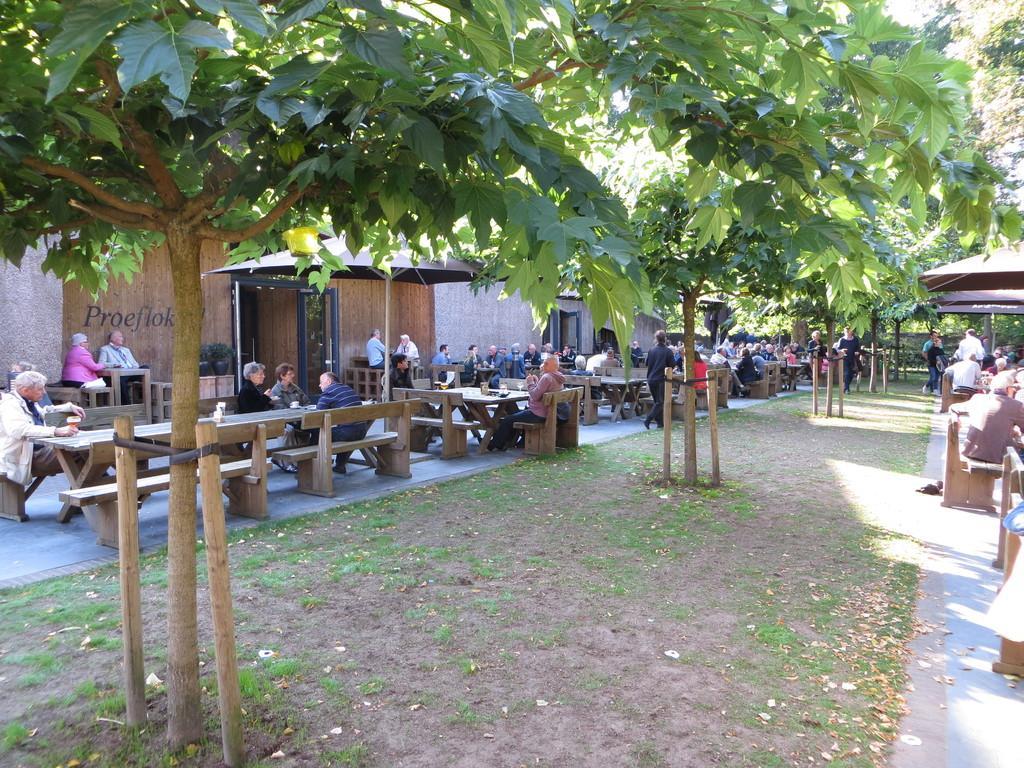Can you describe this image briefly? This picture shows some people are sitting on a bench in front of a table here. There are some trees planted here. We can observe some people sitting here. There is a path on which some trees were planted here. 